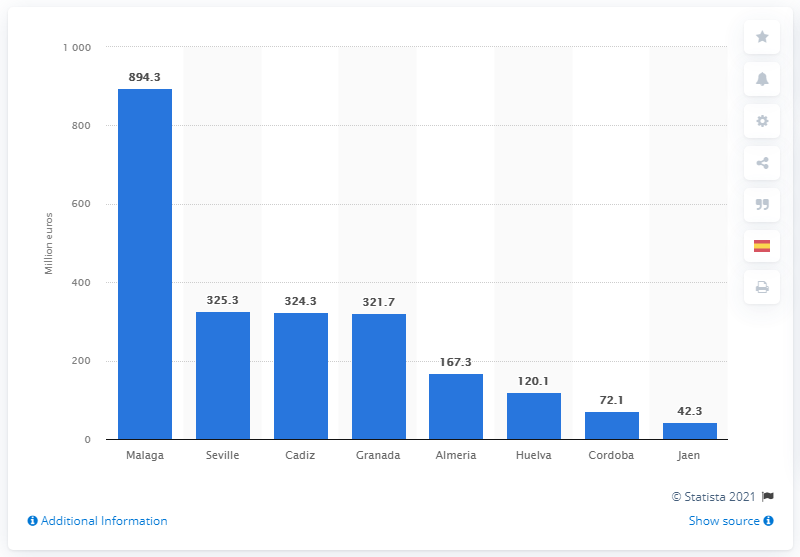Mention a couple of crucial points in this snapshot. The province of Malaga in Andalusia is the most affected by the current economic situation. 